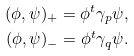<formula> <loc_0><loc_0><loc_500><loc_500>( \phi , \psi ) _ { + } = \phi ^ { t } \gamma _ { p } \psi , \\ ( \phi , \psi ) _ { - } = \phi ^ { t } \gamma _ { q } \psi .</formula> 